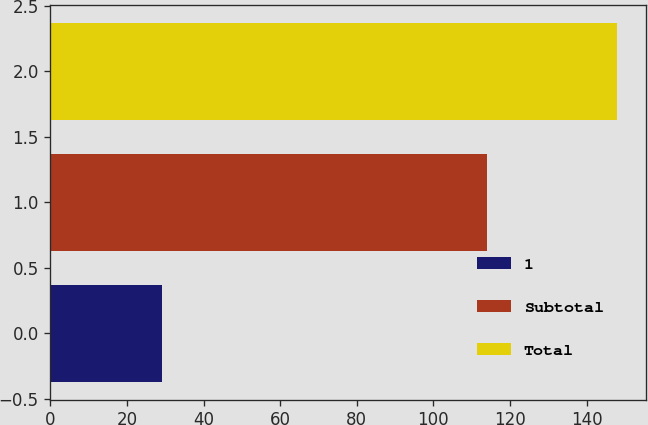Convert chart to OTSL. <chart><loc_0><loc_0><loc_500><loc_500><bar_chart><fcel>1<fcel>Subtotal<fcel>Total<nl><fcel>29<fcel>114<fcel>148<nl></chart> 